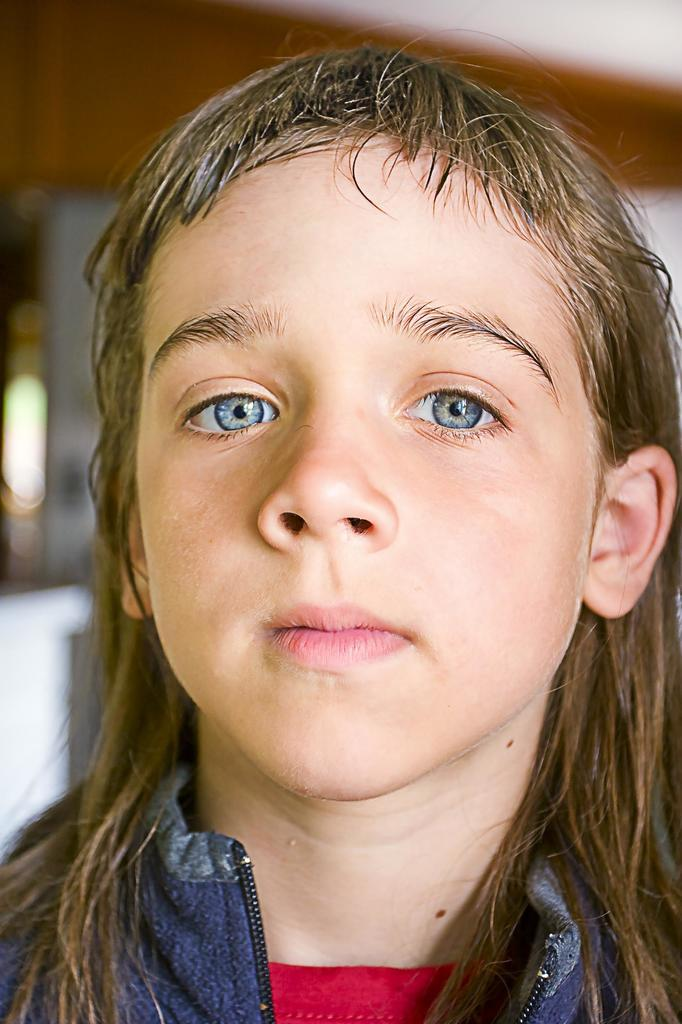What is the main subject in the foreground of the image? There is a kid in the foreground of the image. How would you describe the background of the image? The background of the image is blurred. What type of gun is the kid holding in the image? There is no gun present in the image; the main subject is a kid in the foreground. 